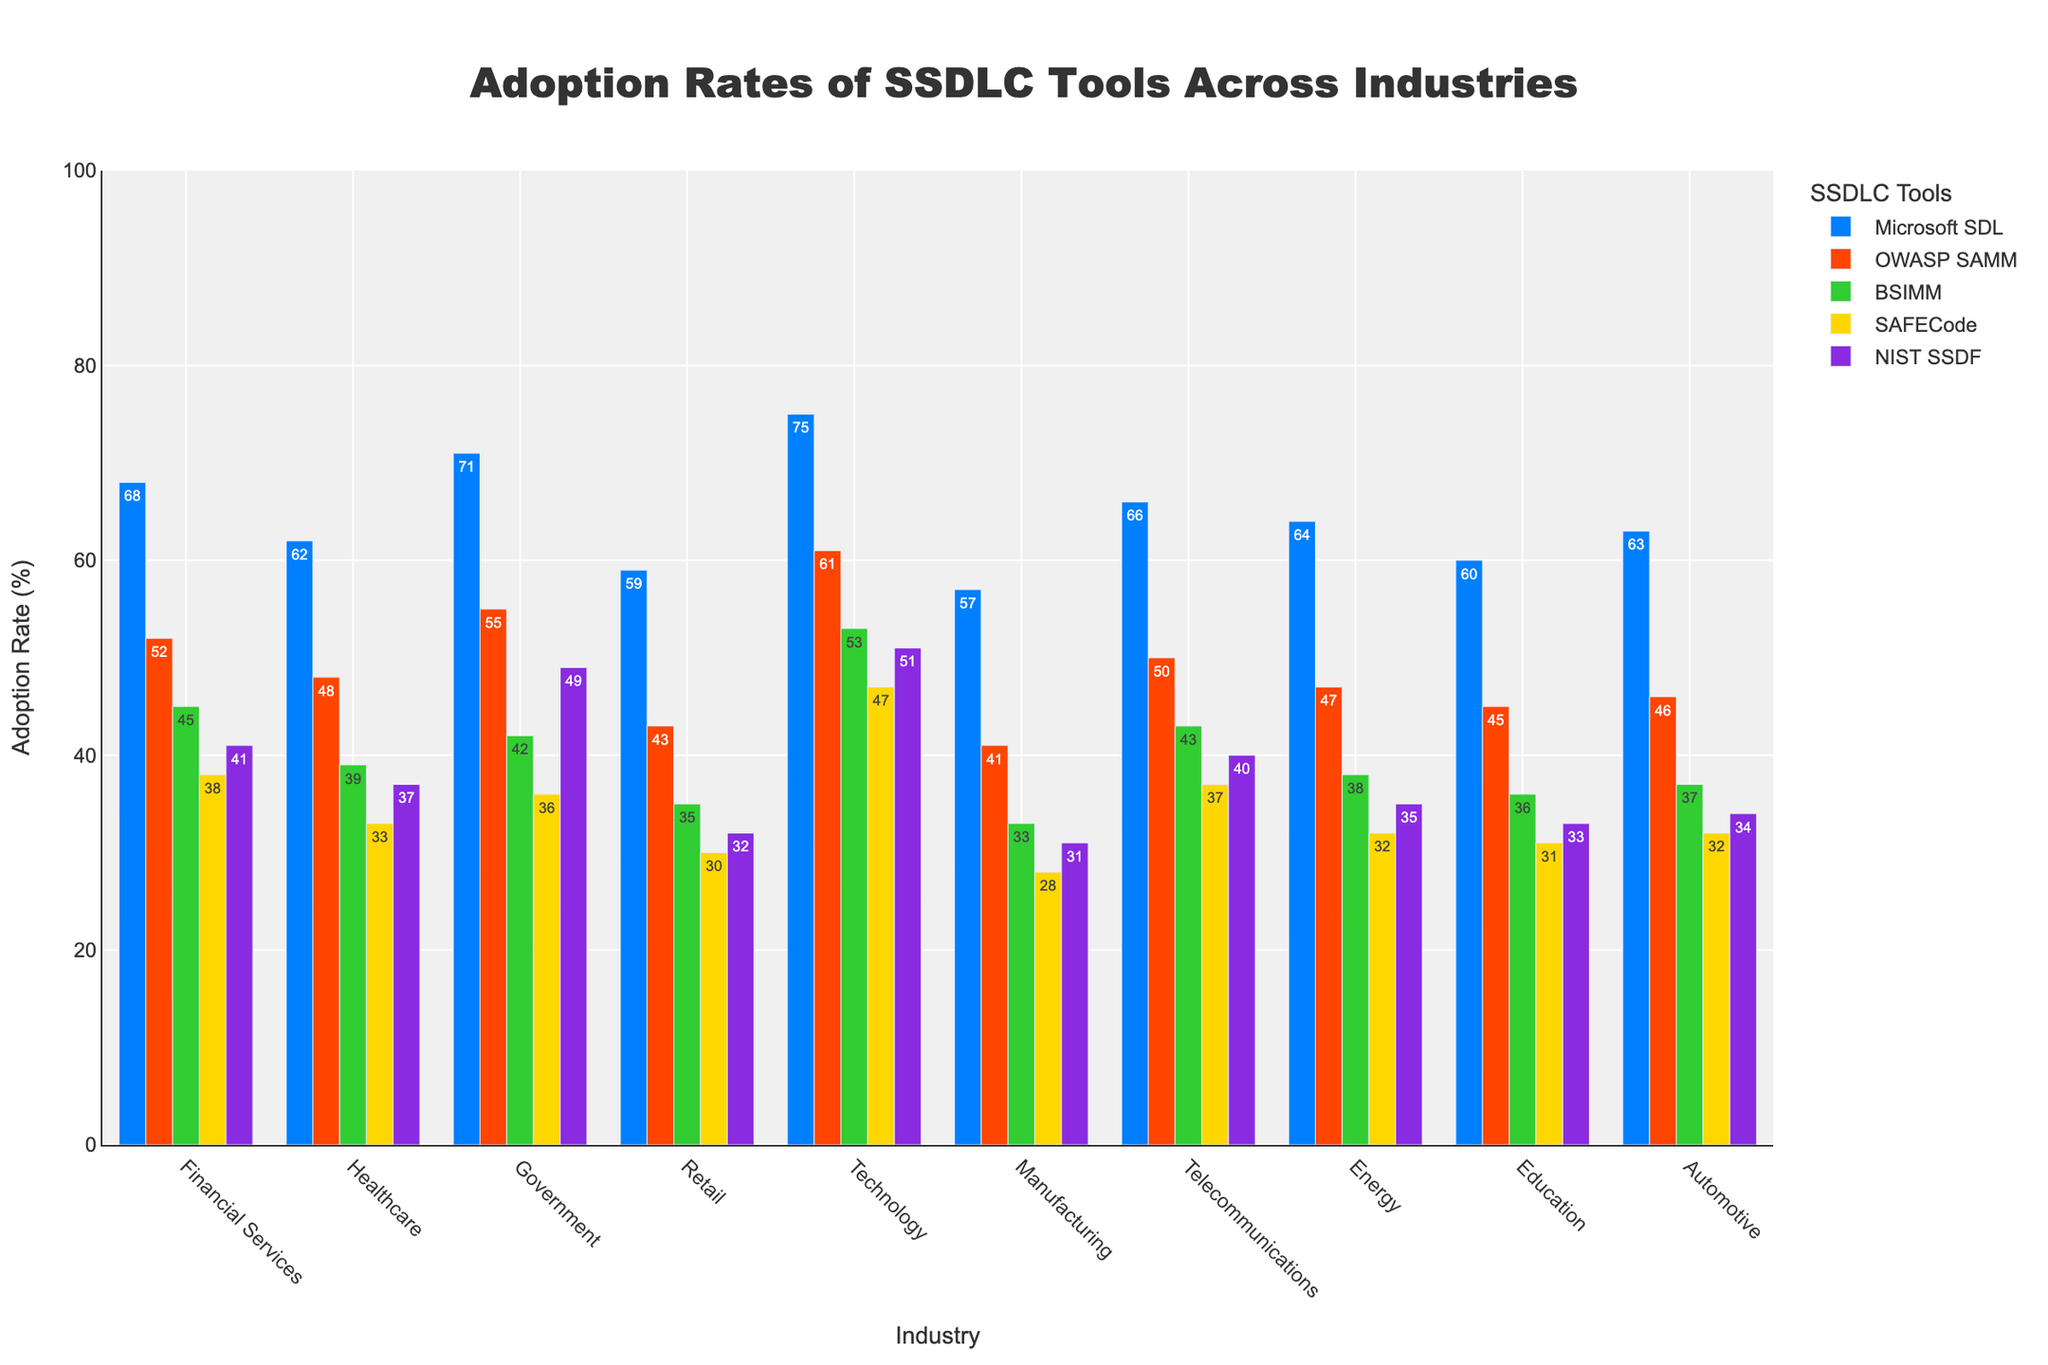Which SSDLC tool has the highest adoption rate in the Technology industry? Look at the bars for the Technology industry and identify the tallest one. The Microsoft SDL bar is the tallest.
Answer: Microsoft SDL What is the difference in the adoption rate of OWASP SAMM between the Government and Retail industries? Identify the heights of the OWASP SAMM bars for Government (55) and Retail (43) industries, then subtract the smaller value from the larger one: 55 - 43 = 12.
Answer: 12 Which industry has the lowest adoption rate for BSIMM? Check all the bars for BSIMM across different industries and find the smallest one. Manufacturing has the shortest BSIMM bar.
Answer: Manufacturing What is the average adoption rate of NIST SSDF in the Financial Services and Government industries? Find the adoption rates of NIST SSDF in Financial Services (41) and Government (49) industries. Compute their average: (41 + 49) / 2 = 45.
Answer: 45 Which tool has a higher adoption rate in the Automotive industry: SAFECode or NIST SSDF? Compare the heights of the SAFECode (32) and NIST SSDF (34) bars in the Automotive industry. The NIST SSDF bar is taller.
Answer: NIST SSDF Calculate the total adoption rate of Microsoft SDL across all industries. Sum the values of Microsoft SDL for all industries: 68 + 62 + 71 + 59 + 75 + 57 + 66 + 64 + 60 + 63 = 645.
Answer: 645 In which industries is the adoption rate of Microsoft SDL over 70%? Identify the industries with Microsoft SDL adoption rates greater than 70. Both Government and Technology have rates over 70%.
Answer: Government, Technology What is the overall trend in the adoption rate of BSIMM across industries compared to that of SAFECode? Compare the heights of the BSIMM and SAFECode bars across all industries. Generally, the bars for BSIMM are slightly higher than those for SAFECode.
Answer: BSIMM higher What is the percentage difference in the adoption rate of Microsoft SDL between Technology and Manufacturing industries? Calculate the adoption rate difference for Microsoft SDL between Technology (75) and Manufacturing (57), then divide by Manufacturing's rate: (75 - 57) / 57 * 100 ≈ 31.58%.
Answer: ≈ 31.58% Which SSDLC tool has the most uniform adoption rate across all industries? Look for the tool whose bars have the least variation in height across all industries. NIST SSDF bars appear to be the most consistently uniform in height.
Answer: NIST SSDF 